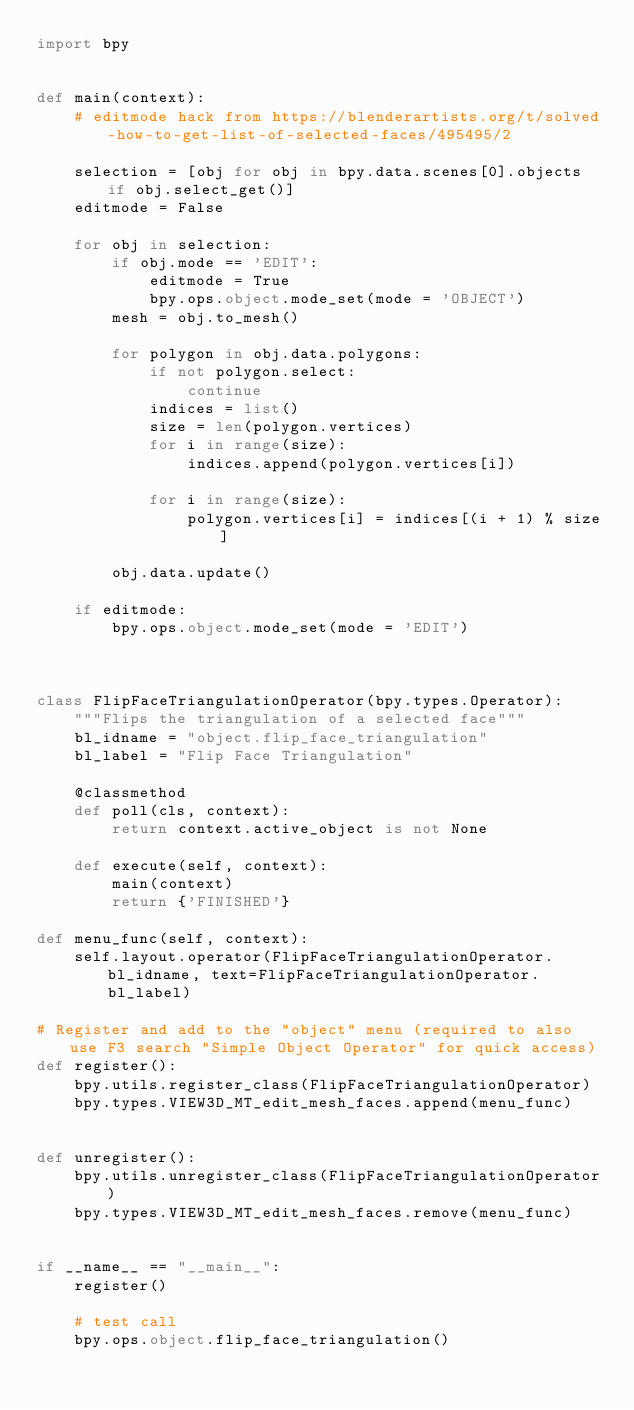<code> <loc_0><loc_0><loc_500><loc_500><_Python_>import bpy


def main(context):
    # editmode hack from https://blenderartists.org/t/solved-how-to-get-list-of-selected-faces/495495/2

    selection = [obj for obj in bpy.data.scenes[0].objects if obj.select_get()]
    editmode = False

    for obj in selection:
        if obj.mode == 'EDIT':
            editmode = True
            bpy.ops.object.mode_set(mode = 'OBJECT')
        mesh = obj.to_mesh()
        
        for polygon in obj.data.polygons:
            if not polygon.select:
                continue
            indices = list()
            size = len(polygon.vertices)
            for i in range(size):
                indices.append(polygon.vertices[i])

            for i in range(size):
                polygon.vertices[i] = indices[(i + 1) % size]

        obj.data.update()

    if editmode:
        bpy.ops.object.mode_set(mode = 'EDIT')



class FlipFaceTriangulationOperator(bpy.types.Operator):
    """Flips the triangulation of a selected face"""
    bl_idname = "object.flip_face_triangulation"
    bl_label = "Flip Face Triangulation"

    @classmethod
    def poll(cls, context):
        return context.active_object is not None

    def execute(self, context):
        main(context)
        return {'FINISHED'}

def menu_func(self, context):
    self.layout.operator(FlipFaceTriangulationOperator.bl_idname, text=FlipFaceTriangulationOperator.bl_label)

# Register and add to the "object" menu (required to also use F3 search "Simple Object Operator" for quick access)
def register():
    bpy.utils.register_class(FlipFaceTriangulationOperator)
    bpy.types.VIEW3D_MT_edit_mesh_faces.append(menu_func)


def unregister():
    bpy.utils.unregister_class(FlipFaceTriangulationOperator)
    bpy.types.VIEW3D_MT_edit_mesh_faces.remove(menu_func)


if __name__ == "__main__":
    register()

    # test call
    bpy.ops.object.flip_face_triangulation()
</code> 